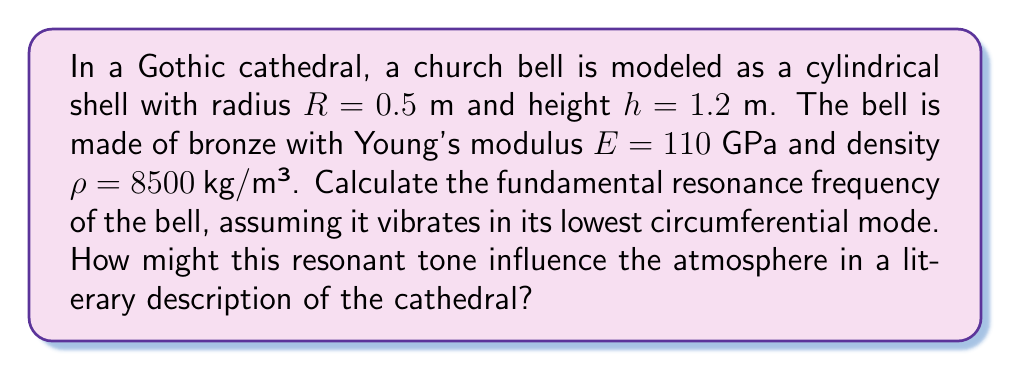Provide a solution to this math problem. To calculate the resonance frequency of the church bell, we'll follow these steps:

1) The fundamental frequency of a cylindrical shell vibrating in its lowest circumferential mode is given by:

   $$f = \frac{1}{2\pi R}\sqrt{\frac{E}{\rho(1-\nu^2)}}$$

   where $\nu$ is Poisson's ratio (approximately 0.34 for bronze).

2) Let's substitute the given values:
   $R = 0.5$ m
   $E = 110 \times 10^9$ Pa
   $\rho = 8500$ kg/m³
   $\nu = 0.34$

3) First, calculate $1-\nu^2$:
   $$1-\nu^2 = 1 - 0.34^2 = 0.8844$$

4) Now, let's substitute all values into the equation:

   $$f = \frac{1}{2\pi(0.5)}\sqrt{\frac{110 \times 10^9}{8500(0.8844)}}$$

5) Simplify:
   $$f = \frac{1}{\pi}\sqrt{\frac{110 \times 10^9}{8500(0.8844)}}$$

6) Calculate:
   $$f \approx 318.6 \text{ Hz}$$

This frequency corresponds to a musical note between D#4 and E4 on the standard musical scale, creating a rich, resonant tone that would reverberate through the Gothic cathedral's vaulted ceilings and stone walls.
Answer: $318.6$ Hz 